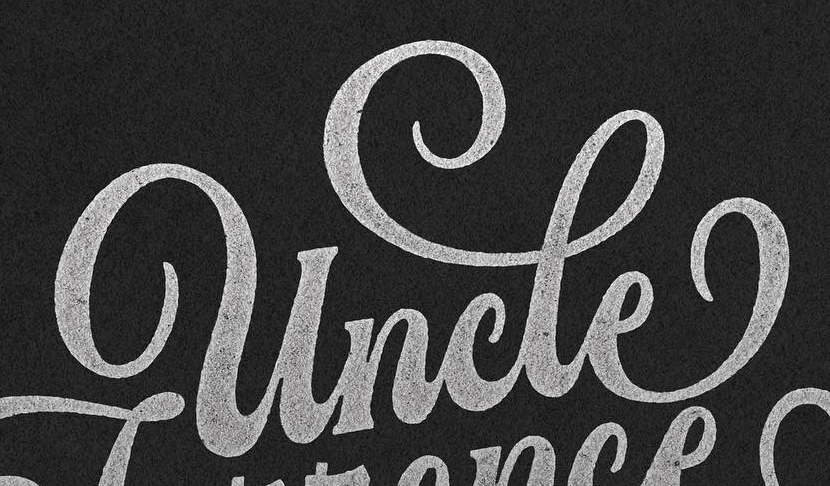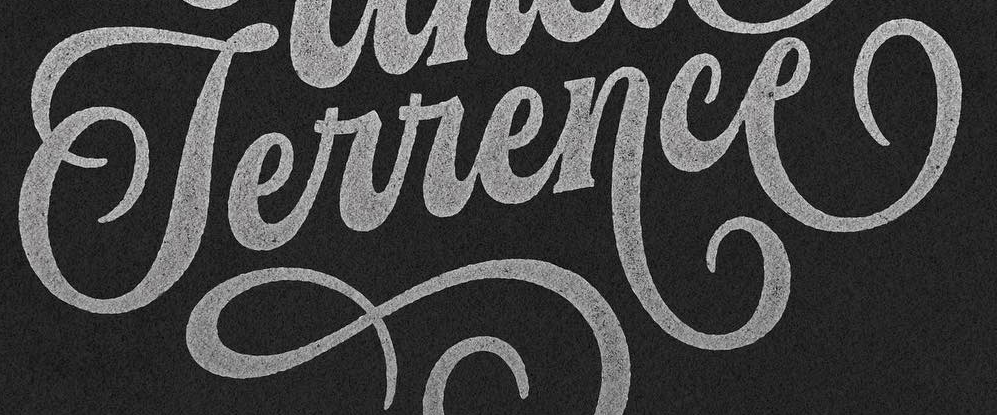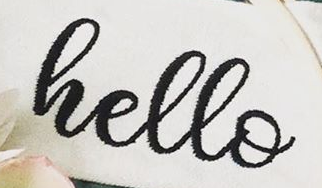What words are shown in these images in order, separated by a semicolon? uncle; Terrence; hello 